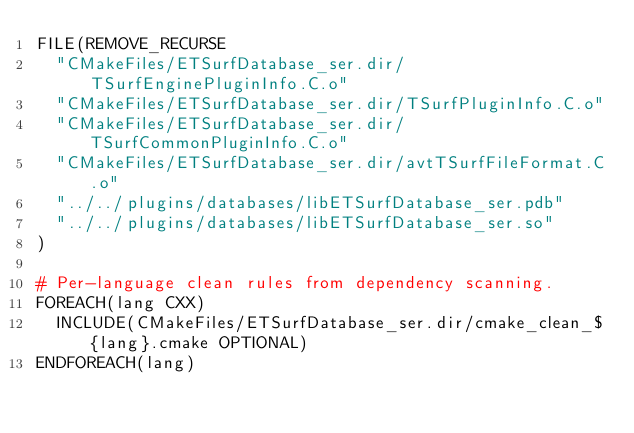Convert code to text. <code><loc_0><loc_0><loc_500><loc_500><_CMake_>FILE(REMOVE_RECURSE
  "CMakeFiles/ETSurfDatabase_ser.dir/TSurfEnginePluginInfo.C.o"
  "CMakeFiles/ETSurfDatabase_ser.dir/TSurfPluginInfo.C.o"
  "CMakeFiles/ETSurfDatabase_ser.dir/TSurfCommonPluginInfo.C.o"
  "CMakeFiles/ETSurfDatabase_ser.dir/avtTSurfFileFormat.C.o"
  "../../plugins/databases/libETSurfDatabase_ser.pdb"
  "../../plugins/databases/libETSurfDatabase_ser.so"
)

# Per-language clean rules from dependency scanning.
FOREACH(lang CXX)
  INCLUDE(CMakeFiles/ETSurfDatabase_ser.dir/cmake_clean_${lang}.cmake OPTIONAL)
ENDFOREACH(lang)
</code> 